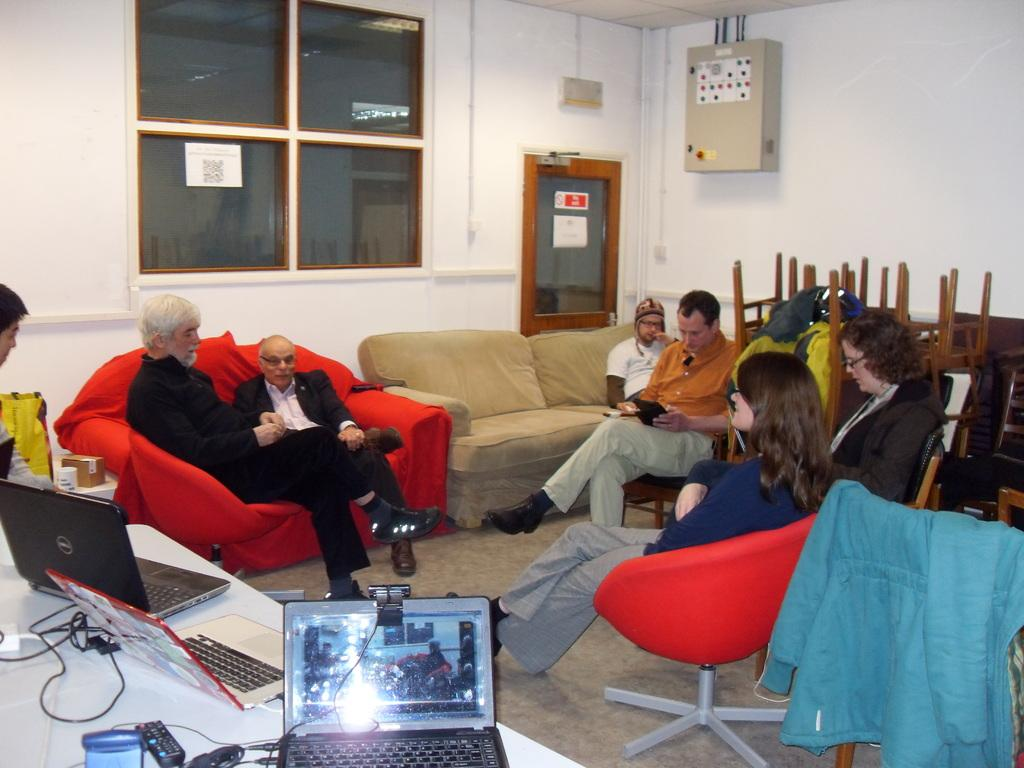What are the people in the image doing? There is a group of people sitting in the image. What type of furniture is present in the image? There is a sofa and chairs in the image. What is on the floor in the image? There is a table on the floor. What electronic devices can be seen on the table? There are laptops on the table. What else is on the table? There are cables and a remote on the table. What can be seen in the background of the image? There is a wall, a glass window, and an electrical device in the background. What type of silk fabric is draped over the sofa in the image? There is no silk fabric present in the image; the sofa is not draped with any fabric. What type of waste can be seen in the image? There is no waste present in the image; the focus is on the people, furniture, and electronic devices. 